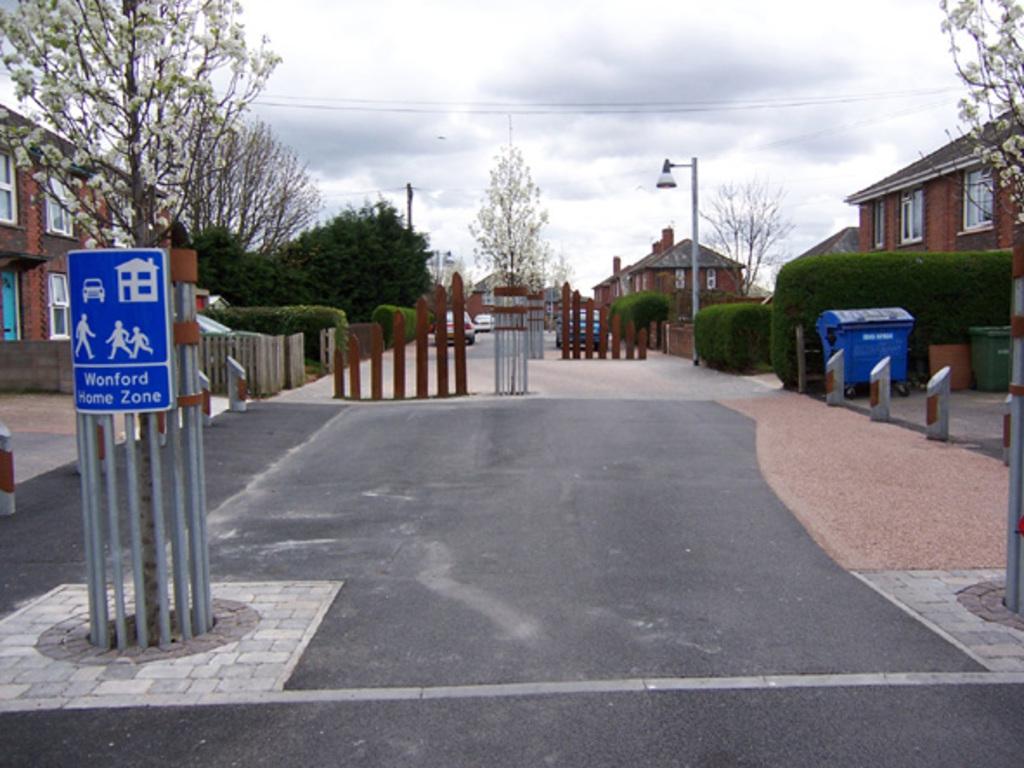This is wonford what?
Ensure brevity in your answer.  Home zone. 